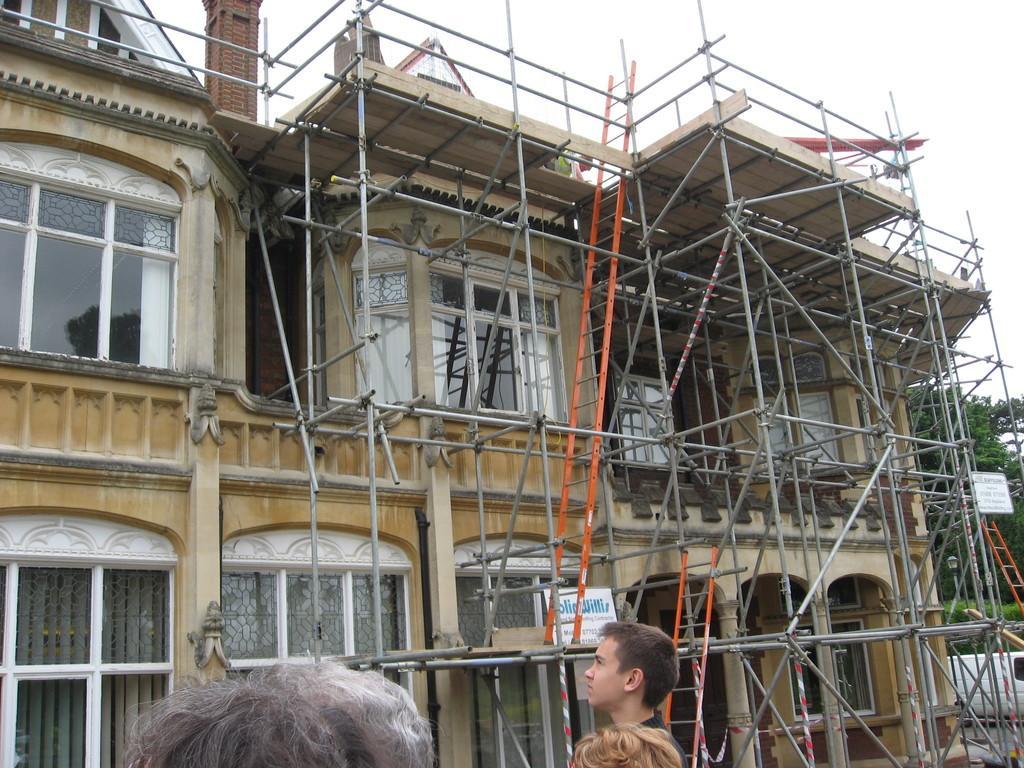Can you describe this image briefly? In this picture I can see a building and few metal rods and i can see trees and few people standing and watching and board to the building with text and a cloudy sky and may be the building is under renovation. 